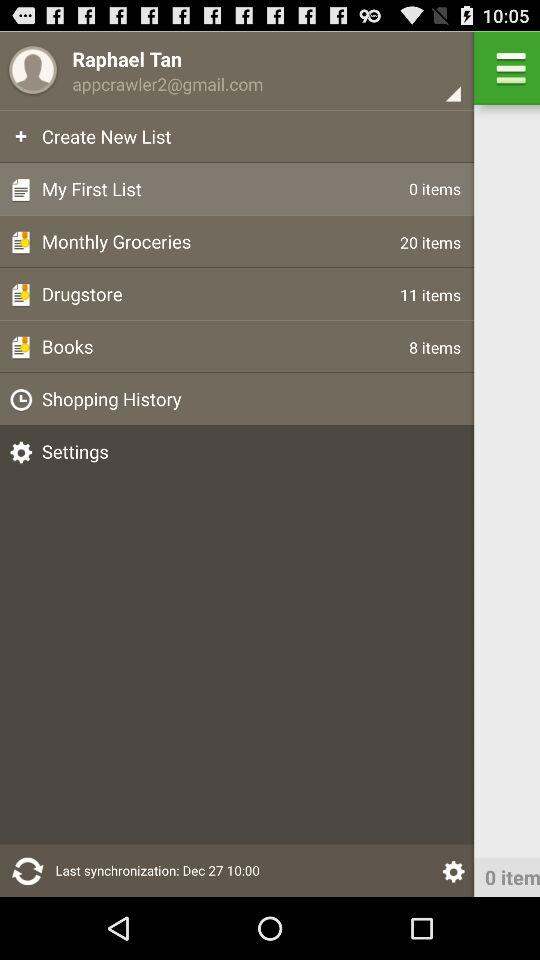What is the email address? The email address is appcrawler2@gmail.com. 